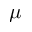Convert formula to latex. <formula><loc_0><loc_0><loc_500><loc_500>\mu</formula> 